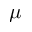Convert formula to latex. <formula><loc_0><loc_0><loc_500><loc_500>\mu</formula> 